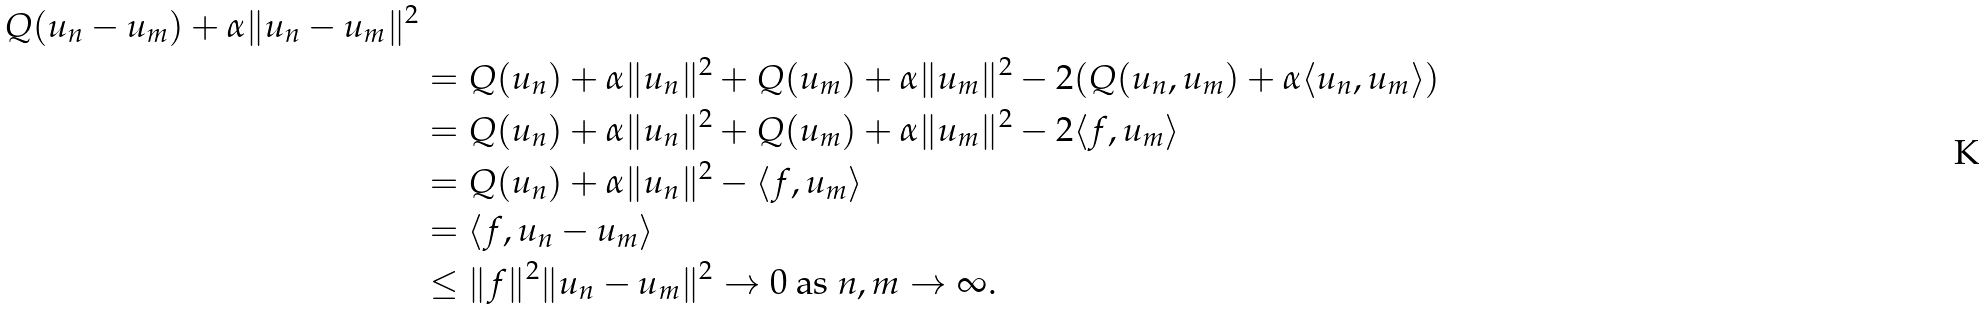Convert formula to latex. <formula><loc_0><loc_0><loc_500><loc_500>{ Q ( u _ { n } - u _ { m } ) + \alpha \| u _ { n } - u _ { m } \| ^ { 2 } } \\ & = Q ( u _ { n } ) + \alpha \| u _ { n } \| ^ { 2 } + Q ( u _ { m } ) + \alpha \| u _ { m } \| ^ { 2 } - 2 ( Q ( u _ { n } , u _ { m } ) + \alpha \langle u _ { n } , u _ { m } \rangle ) \\ & = Q ( u _ { n } ) + \alpha \| u _ { n } \| ^ { 2 } + Q ( u _ { m } ) + \alpha \| u _ { m } \| ^ { 2 } - 2 \langle f , u _ { m } \rangle \\ & = Q ( u _ { n } ) + \alpha \| u _ { n } \| ^ { 2 } - \langle f , u _ { m } \rangle \\ & = \langle f , u _ { n } - u _ { m } \rangle \\ & \leq \| f \| ^ { 2 } \| u _ { n } - u _ { m } \| ^ { 2 } \to 0 \text { as } n , m \to \infty .</formula> 